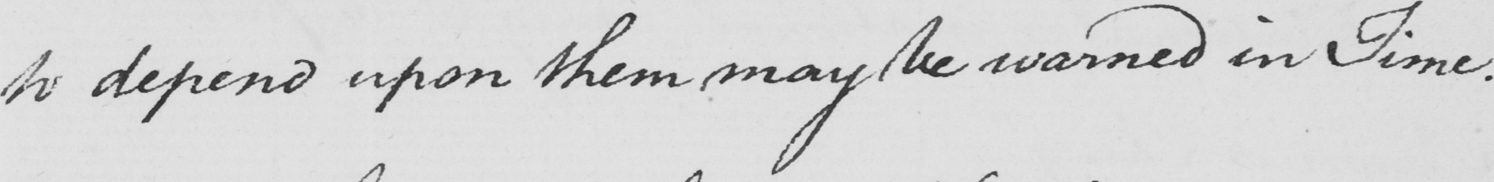What text is written in this handwritten line? to depend upon them may be warned in Time . 